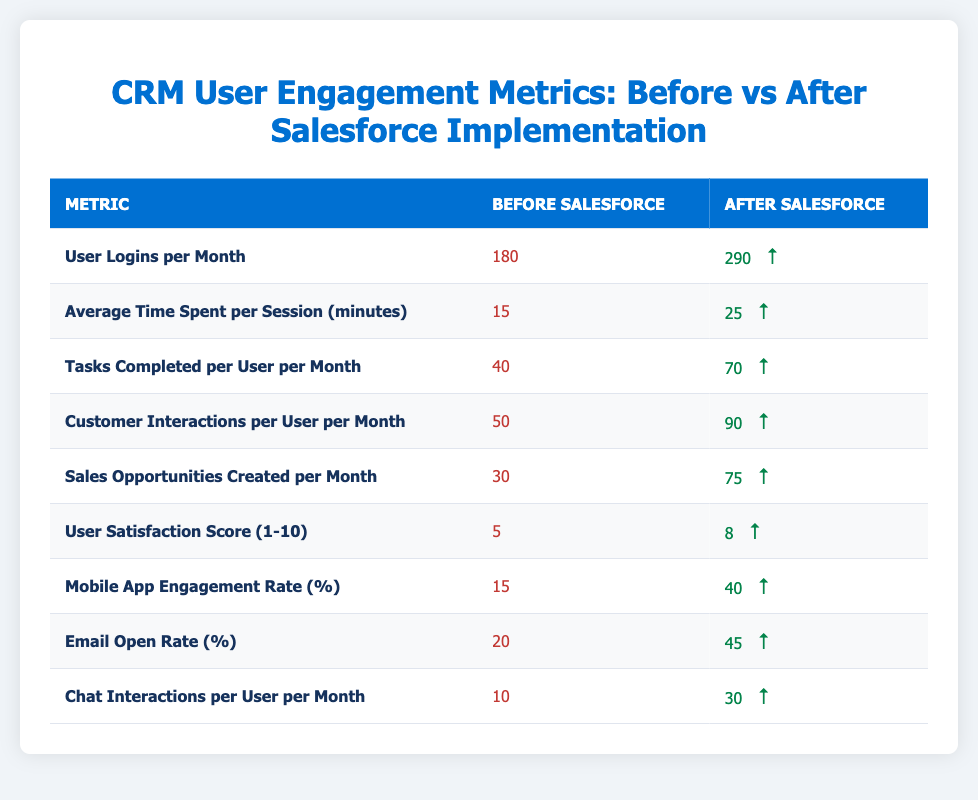What were the User Logins per Month before Salesforce implementation? According to the table, the User Logins per Month before Salesforce was listed as 180.
Answer: 180 What is the difference in Tasks Completed per User per Month before and after Salesforce? The before value is 40 and the after value is 70. The difference is calculated as 70 - 40, which equals 30.
Answer: 30 Is the User Satisfaction Score higher after Salesforce implementation compared to before? The User Satisfaction Score before Salesforce was 5 and after it was 8. Since 8 is greater than 5, the answer is yes.
Answer: Yes What is the total number of Sales Opportunities Created per Month before Salesforce implementation? From the table, the number of Sales Opportunities Created per Month before Salesforce implementation is 30.
Answer: 30 How much did the Average Time Spent per Session increase after Salesforce? The Average Time Spent per Session was 15 minutes before Salesforce and increased to 25 minutes after. The increase is calculated as 25 - 15, resulting in an increase of 10 minutes.
Answer: 10 minutes What is the percentage increase in Mobile App Engagement Rate after Salesforce? The engagement rate increased from 15% to 40%. To find the percentage increase, the formula is ((40 - 15) / 15) * 100 = 166.67%. This shows that the engagement rate increased by about 166.67%.
Answer: 166.67% How many more Customer Interactions per User per Month are there after Salesforce? The Customer Interactions per User was 50 before and increased to 90 after. The additional interactions are calculated as 90 - 50, which equals 40.
Answer: 40 Was the Email Open Rate before Salesforce implementation below the threshold of 25%? The Email Open Rate before Salesforce implementation was 20%, which is indeed below 25%. Therefore, the answer is yes.
Answer: Yes What was the ratio of Sales Opportunities Created per Month after Salesforce to User Logins per Month after Salesforce? After Salesforce, 75 Sales Opportunities were created and there were 290 User Logins. The ratio is calculated as 75:290, which simplifies to approximately 1:3.87.
Answer: 1:3.87 